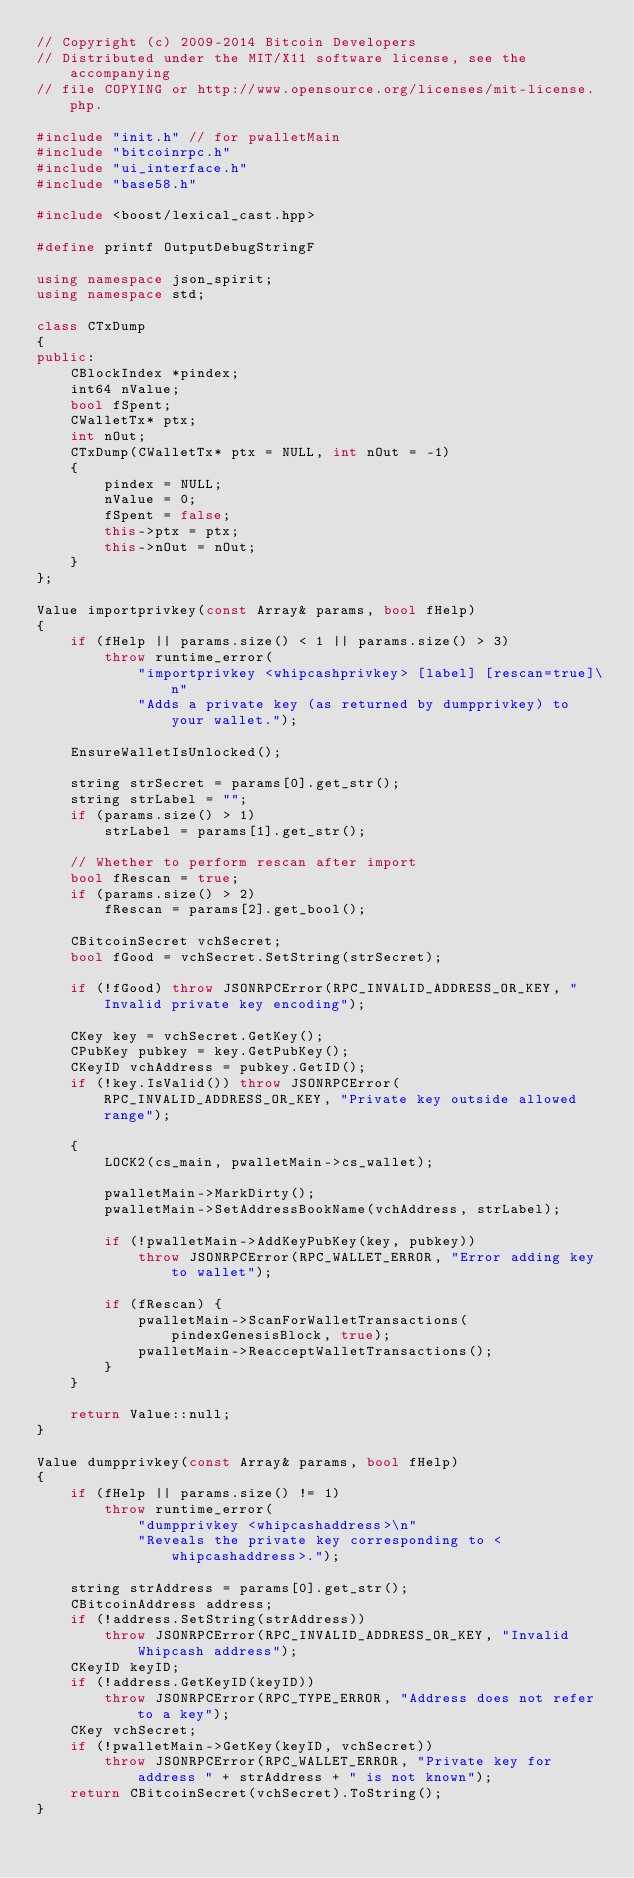<code> <loc_0><loc_0><loc_500><loc_500><_C++_>// Copyright (c) 2009-2014 Bitcoin Developers
// Distributed under the MIT/X11 software license, see the accompanying
// file COPYING or http://www.opensource.org/licenses/mit-license.php.

#include "init.h" // for pwalletMain
#include "bitcoinrpc.h"
#include "ui_interface.h"
#include "base58.h"

#include <boost/lexical_cast.hpp>

#define printf OutputDebugStringF

using namespace json_spirit;
using namespace std;

class CTxDump
{
public:
    CBlockIndex *pindex;
    int64 nValue;
    bool fSpent;
    CWalletTx* ptx;
    int nOut;
    CTxDump(CWalletTx* ptx = NULL, int nOut = -1)
    {
        pindex = NULL;
        nValue = 0;
        fSpent = false;
        this->ptx = ptx;
        this->nOut = nOut;
    }
};

Value importprivkey(const Array& params, bool fHelp)
{
    if (fHelp || params.size() < 1 || params.size() > 3)
        throw runtime_error(
            "importprivkey <whipcashprivkey> [label] [rescan=true]\n"
            "Adds a private key (as returned by dumpprivkey) to your wallet.");

    EnsureWalletIsUnlocked();

    string strSecret = params[0].get_str();
    string strLabel = "";
    if (params.size() > 1)
        strLabel = params[1].get_str();

    // Whether to perform rescan after import
    bool fRescan = true;
    if (params.size() > 2)
        fRescan = params[2].get_bool();

    CBitcoinSecret vchSecret;
    bool fGood = vchSecret.SetString(strSecret);

    if (!fGood) throw JSONRPCError(RPC_INVALID_ADDRESS_OR_KEY, "Invalid private key encoding");

    CKey key = vchSecret.GetKey();
    CPubKey pubkey = key.GetPubKey();
    CKeyID vchAddress = pubkey.GetID();
    if (!key.IsValid()) throw JSONRPCError(RPC_INVALID_ADDRESS_OR_KEY, "Private key outside allowed range");

    {
        LOCK2(cs_main, pwalletMain->cs_wallet);

        pwalletMain->MarkDirty();
        pwalletMain->SetAddressBookName(vchAddress, strLabel);

        if (!pwalletMain->AddKeyPubKey(key, pubkey))
            throw JSONRPCError(RPC_WALLET_ERROR, "Error adding key to wallet");

        if (fRescan) {
            pwalletMain->ScanForWalletTransactions(pindexGenesisBlock, true);
            pwalletMain->ReacceptWalletTransactions();
        }
    }

    return Value::null;
}

Value dumpprivkey(const Array& params, bool fHelp)
{
    if (fHelp || params.size() != 1)
        throw runtime_error(
            "dumpprivkey <whipcashaddress>\n"
            "Reveals the private key corresponding to <whipcashaddress>.");

    string strAddress = params[0].get_str();
    CBitcoinAddress address;
    if (!address.SetString(strAddress))
        throw JSONRPCError(RPC_INVALID_ADDRESS_OR_KEY, "Invalid Whipcash address");
    CKeyID keyID;
    if (!address.GetKeyID(keyID))
        throw JSONRPCError(RPC_TYPE_ERROR, "Address does not refer to a key");
    CKey vchSecret;
    if (!pwalletMain->GetKey(keyID, vchSecret))
        throw JSONRPCError(RPC_WALLET_ERROR, "Private key for address " + strAddress + " is not known");
    return CBitcoinSecret(vchSecret).ToString();
}
</code> 